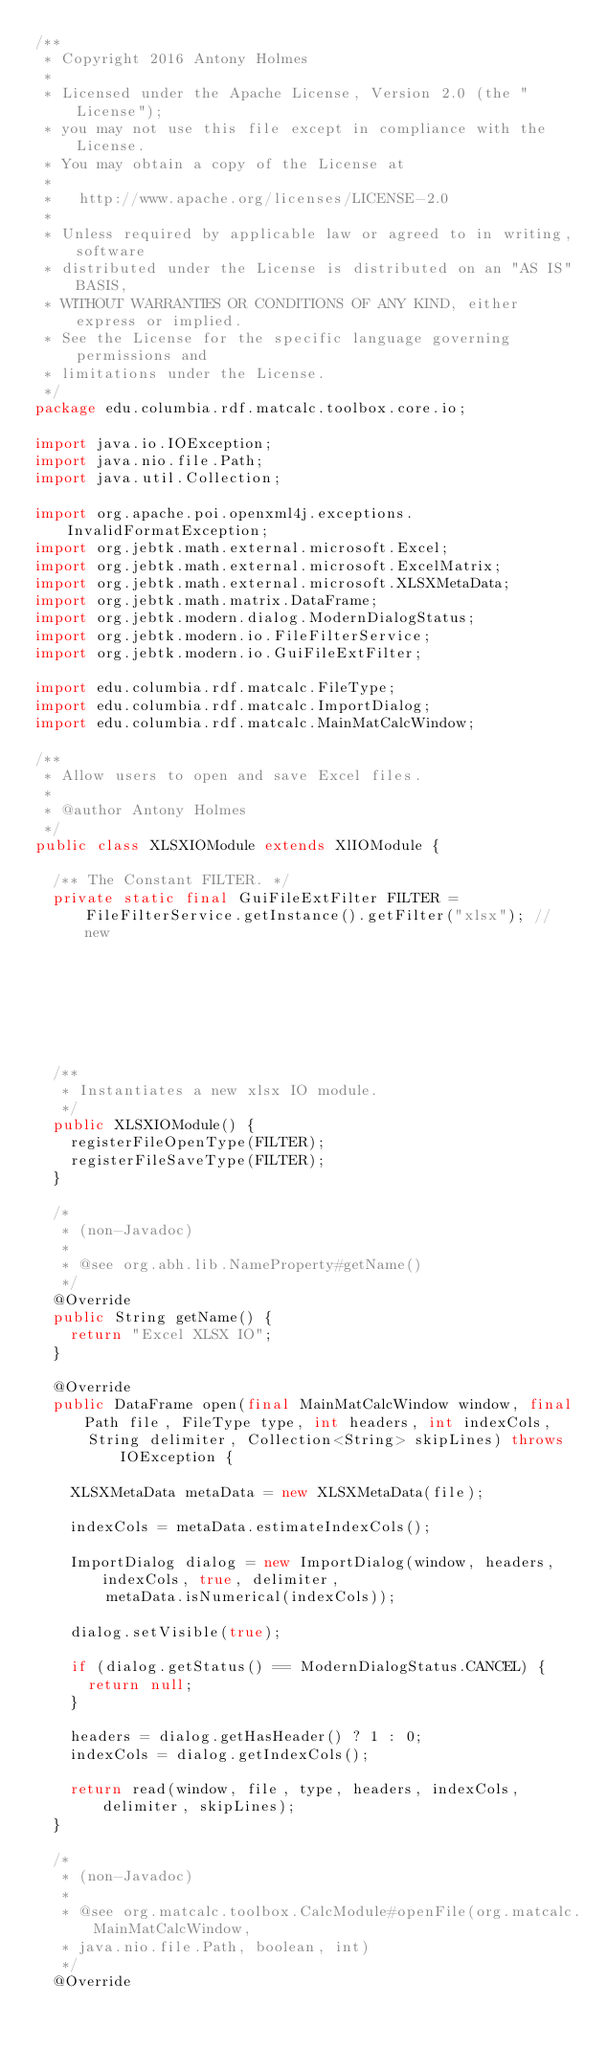<code> <loc_0><loc_0><loc_500><loc_500><_Java_>/**
 * Copyright 2016 Antony Holmes
 *
 * Licensed under the Apache License, Version 2.0 (the "License");
 * you may not use this file except in compliance with the License.
 * You may obtain a copy of the License at
 * 
 *   http://www.apache.org/licenses/LICENSE-2.0
 * 
 * Unless required by applicable law or agreed to in writing, software
 * distributed under the License is distributed on an "AS IS" BASIS,
 * WITHOUT WARRANTIES OR CONDITIONS OF ANY KIND, either express or implied.
 * See the License for the specific language governing permissions and
 * limitations under the License.
 */
package edu.columbia.rdf.matcalc.toolbox.core.io;

import java.io.IOException;
import java.nio.file.Path;
import java.util.Collection;

import org.apache.poi.openxml4j.exceptions.InvalidFormatException;
import org.jebtk.math.external.microsoft.Excel;
import org.jebtk.math.external.microsoft.ExcelMatrix;
import org.jebtk.math.external.microsoft.XLSXMetaData;
import org.jebtk.math.matrix.DataFrame;
import org.jebtk.modern.dialog.ModernDialogStatus;
import org.jebtk.modern.io.FileFilterService;
import org.jebtk.modern.io.GuiFileExtFilter;

import edu.columbia.rdf.matcalc.FileType;
import edu.columbia.rdf.matcalc.ImportDialog;
import edu.columbia.rdf.matcalc.MainMatCalcWindow;

/**
 * Allow users to open and save Excel files.
 *
 * @author Antony Holmes
 */
public class XLSXIOModule extends XlIOModule {

  /** The Constant FILTER. */
  private static final GuiFileExtFilter FILTER = FileFilterService.getInstance().getFilter("xlsx"); // new
                                                                                                    // XlsxGuiFileFilter();

  /**
   * Instantiates a new xlsx IO module.
   */
  public XLSXIOModule() {
    registerFileOpenType(FILTER);
    registerFileSaveType(FILTER);
  }

  /*
   * (non-Javadoc)
   * 
   * @see org.abh.lib.NameProperty#getName()
   */
  @Override
  public String getName() {
    return "Excel XLSX IO";
  }

  @Override
  public DataFrame open(final MainMatCalcWindow window, final Path file, FileType type, int headers, int indexCols,
      String delimiter, Collection<String> skipLines) throws IOException {

    XLSXMetaData metaData = new XLSXMetaData(file);

    indexCols = metaData.estimateIndexCols();

    ImportDialog dialog = new ImportDialog(window, headers, indexCols, true, delimiter,
        metaData.isNumerical(indexCols));

    dialog.setVisible(true);

    if (dialog.getStatus() == ModernDialogStatus.CANCEL) {
      return null;
    }

    headers = dialog.getHasHeader() ? 1 : 0;
    indexCols = dialog.getIndexCols();

    return read(window, file, type, headers, indexCols, delimiter, skipLines);
  }

  /*
   * (non-Javadoc)
   * 
   * @see org.matcalc.toolbox.CalcModule#openFile(org.matcalc.MainMatCalcWindow,
   * java.nio.file.Path, boolean, int)
   */
  @Override</code> 